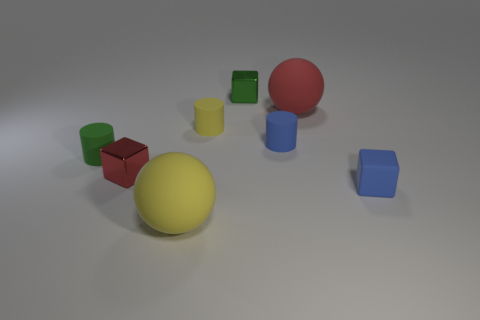Add 1 small red metallic blocks. How many objects exist? 9 Subtract all cubes. How many objects are left? 5 Subtract 0 purple balls. How many objects are left? 8 Subtract all large cyan rubber cubes. Subtract all matte cylinders. How many objects are left? 5 Add 7 spheres. How many spheres are left? 9 Add 2 big yellow rubber things. How many big yellow rubber things exist? 3 